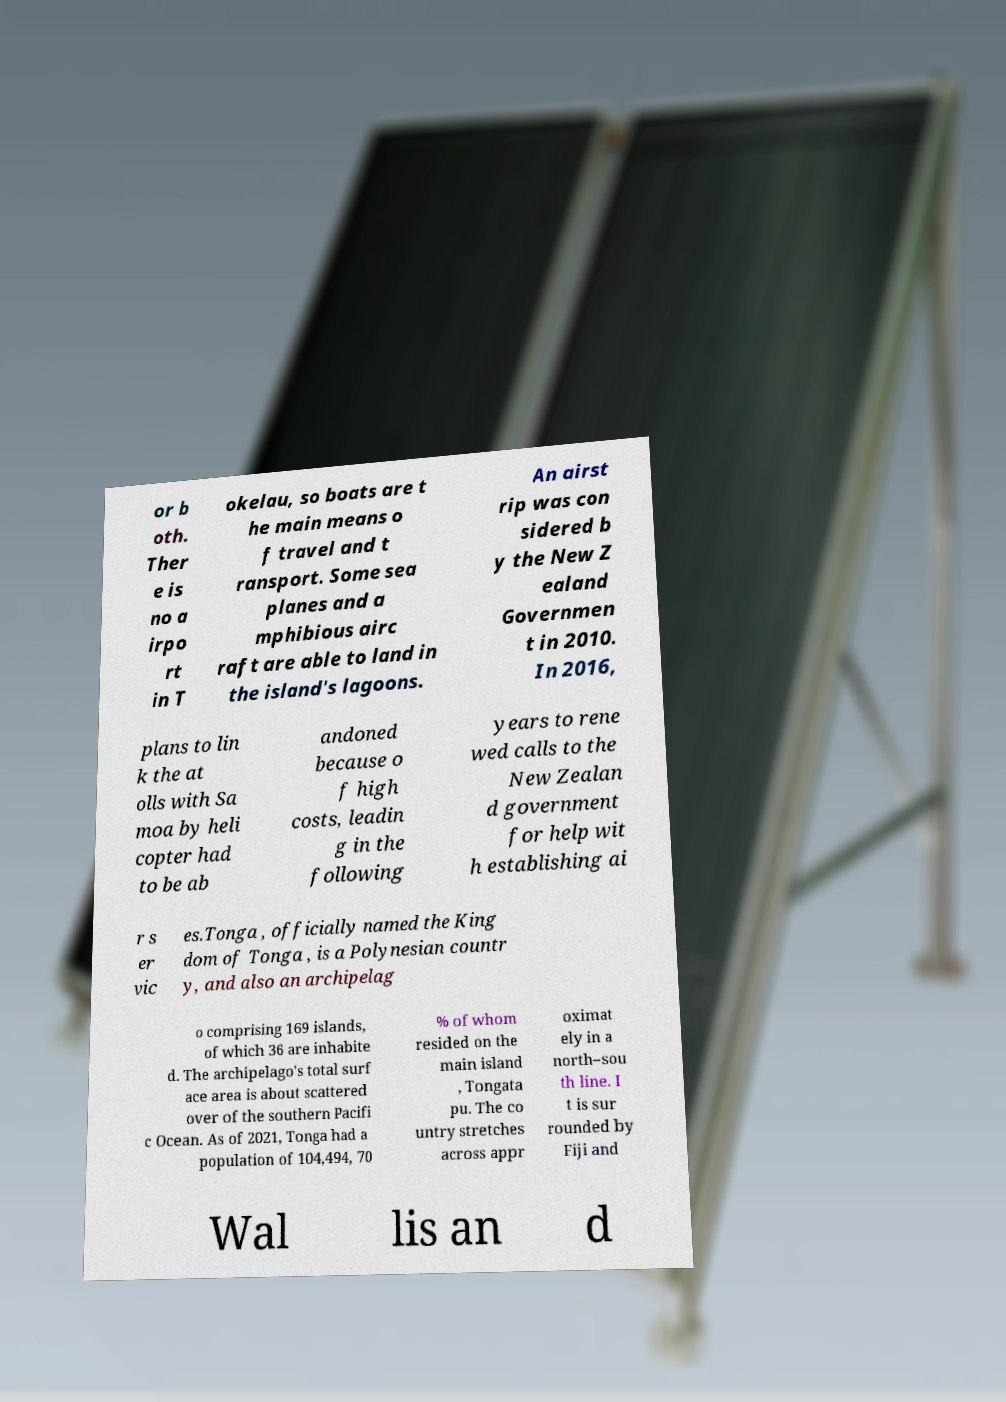Can you accurately transcribe the text from the provided image for me? or b oth. Ther e is no a irpo rt in T okelau, so boats are t he main means o f travel and t ransport. Some sea planes and a mphibious airc raft are able to land in the island's lagoons. An airst rip was con sidered b y the New Z ealand Governmen t in 2010. In 2016, plans to lin k the at olls with Sa moa by heli copter had to be ab andoned because o f high costs, leadin g in the following years to rene wed calls to the New Zealan d government for help wit h establishing ai r s er vic es.Tonga , officially named the King dom of Tonga , is a Polynesian countr y, and also an archipelag o comprising 169 islands, of which 36 are inhabite d. The archipelago's total surf ace area is about scattered over of the southern Pacifi c Ocean. As of 2021, Tonga had a population of 104,494, 70 % of whom resided on the main island , Tongata pu. The co untry stretches across appr oximat ely in a north–sou th line. I t is sur rounded by Fiji and Wal lis an d 